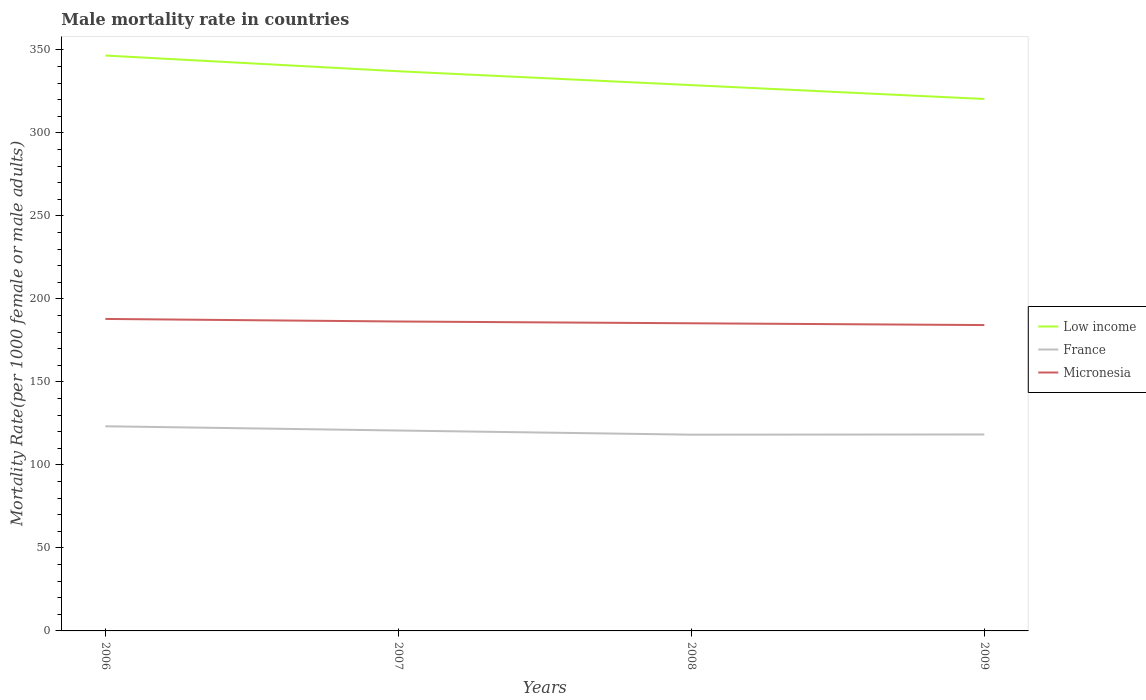Across all years, what is the maximum male mortality rate in France?
Your answer should be very brief. 118.23. In which year was the male mortality rate in France maximum?
Offer a terse response. 2008. What is the total male mortality rate in Low income in the graph?
Provide a succinct answer. 8.34. What is the difference between the highest and the second highest male mortality rate in Micronesia?
Provide a succinct answer. 3.68. What is the difference between the highest and the lowest male mortality rate in France?
Provide a short and direct response. 2. Is the male mortality rate in France strictly greater than the male mortality rate in Micronesia over the years?
Provide a succinct answer. Yes. How many lines are there?
Provide a succinct answer. 3. How many years are there in the graph?
Give a very brief answer. 4. What is the difference between two consecutive major ticks on the Y-axis?
Keep it short and to the point. 50. Does the graph contain any zero values?
Your answer should be very brief. No. How many legend labels are there?
Keep it short and to the point. 3. What is the title of the graph?
Make the answer very short. Male mortality rate in countries. What is the label or title of the Y-axis?
Your answer should be very brief. Mortality Rate(per 1000 female or male adults). What is the Mortality Rate(per 1000 female or male adults) in Low income in 2006?
Offer a very short reply. 346.65. What is the Mortality Rate(per 1000 female or male adults) in France in 2006?
Provide a succinct answer. 123.29. What is the Mortality Rate(per 1000 female or male adults) in Micronesia in 2006?
Offer a very short reply. 187.96. What is the Mortality Rate(per 1000 female or male adults) of Low income in 2007?
Keep it short and to the point. 337.17. What is the Mortality Rate(per 1000 female or male adults) of France in 2007?
Offer a terse response. 120.74. What is the Mortality Rate(per 1000 female or male adults) of Micronesia in 2007?
Keep it short and to the point. 186.42. What is the Mortality Rate(per 1000 female or male adults) of Low income in 2008?
Provide a short and direct response. 328.81. What is the Mortality Rate(per 1000 female or male adults) of France in 2008?
Offer a very short reply. 118.23. What is the Mortality Rate(per 1000 female or male adults) in Micronesia in 2008?
Provide a short and direct response. 185.34. What is the Mortality Rate(per 1000 female or male adults) of Low income in 2009?
Ensure brevity in your answer.  320.47. What is the Mortality Rate(per 1000 female or male adults) in France in 2009?
Provide a succinct answer. 118.35. What is the Mortality Rate(per 1000 female or male adults) of Micronesia in 2009?
Make the answer very short. 184.27. Across all years, what is the maximum Mortality Rate(per 1000 female or male adults) in Low income?
Your answer should be compact. 346.65. Across all years, what is the maximum Mortality Rate(per 1000 female or male adults) of France?
Make the answer very short. 123.29. Across all years, what is the maximum Mortality Rate(per 1000 female or male adults) in Micronesia?
Provide a short and direct response. 187.96. Across all years, what is the minimum Mortality Rate(per 1000 female or male adults) of Low income?
Provide a short and direct response. 320.47. Across all years, what is the minimum Mortality Rate(per 1000 female or male adults) in France?
Ensure brevity in your answer.  118.23. Across all years, what is the minimum Mortality Rate(per 1000 female or male adults) of Micronesia?
Your response must be concise. 184.27. What is the total Mortality Rate(per 1000 female or male adults) of Low income in the graph?
Make the answer very short. 1333.11. What is the total Mortality Rate(per 1000 female or male adults) of France in the graph?
Your answer should be compact. 480.61. What is the total Mortality Rate(per 1000 female or male adults) in Micronesia in the graph?
Make the answer very short. 743.99. What is the difference between the Mortality Rate(per 1000 female or male adults) of Low income in 2006 and that in 2007?
Ensure brevity in your answer.  9.47. What is the difference between the Mortality Rate(per 1000 female or male adults) in France in 2006 and that in 2007?
Provide a short and direct response. 2.55. What is the difference between the Mortality Rate(per 1000 female or male adults) in Micronesia in 2006 and that in 2007?
Your response must be concise. 1.54. What is the difference between the Mortality Rate(per 1000 female or male adults) of Low income in 2006 and that in 2008?
Offer a terse response. 17.83. What is the difference between the Mortality Rate(per 1000 female or male adults) of France in 2006 and that in 2008?
Provide a succinct answer. 5.06. What is the difference between the Mortality Rate(per 1000 female or male adults) of Micronesia in 2006 and that in 2008?
Make the answer very short. 2.61. What is the difference between the Mortality Rate(per 1000 female or male adults) of Low income in 2006 and that in 2009?
Offer a very short reply. 26.17. What is the difference between the Mortality Rate(per 1000 female or male adults) in France in 2006 and that in 2009?
Offer a terse response. 4.94. What is the difference between the Mortality Rate(per 1000 female or male adults) in Micronesia in 2006 and that in 2009?
Provide a succinct answer. 3.68. What is the difference between the Mortality Rate(per 1000 female or male adults) of Low income in 2007 and that in 2008?
Make the answer very short. 8.36. What is the difference between the Mortality Rate(per 1000 female or male adults) in France in 2007 and that in 2008?
Give a very brief answer. 2.51. What is the difference between the Mortality Rate(per 1000 female or male adults) of Micronesia in 2007 and that in 2008?
Provide a short and direct response. 1.07. What is the difference between the Mortality Rate(per 1000 female or male adults) in Low income in 2007 and that in 2009?
Provide a succinct answer. 16.7. What is the difference between the Mortality Rate(per 1000 female or male adults) in France in 2007 and that in 2009?
Offer a terse response. 2.39. What is the difference between the Mortality Rate(per 1000 female or male adults) in Micronesia in 2007 and that in 2009?
Make the answer very short. 2.15. What is the difference between the Mortality Rate(per 1000 female or male adults) in Low income in 2008 and that in 2009?
Make the answer very short. 8.34. What is the difference between the Mortality Rate(per 1000 female or male adults) in France in 2008 and that in 2009?
Ensure brevity in your answer.  -0.12. What is the difference between the Mortality Rate(per 1000 female or male adults) of Micronesia in 2008 and that in 2009?
Ensure brevity in your answer.  1.07. What is the difference between the Mortality Rate(per 1000 female or male adults) in Low income in 2006 and the Mortality Rate(per 1000 female or male adults) in France in 2007?
Your answer should be compact. 225.91. What is the difference between the Mortality Rate(per 1000 female or male adults) in Low income in 2006 and the Mortality Rate(per 1000 female or male adults) in Micronesia in 2007?
Make the answer very short. 160.23. What is the difference between the Mortality Rate(per 1000 female or male adults) in France in 2006 and the Mortality Rate(per 1000 female or male adults) in Micronesia in 2007?
Your answer should be very brief. -63.12. What is the difference between the Mortality Rate(per 1000 female or male adults) in Low income in 2006 and the Mortality Rate(per 1000 female or male adults) in France in 2008?
Your answer should be compact. 228.42. What is the difference between the Mortality Rate(per 1000 female or male adults) of Low income in 2006 and the Mortality Rate(per 1000 female or male adults) of Micronesia in 2008?
Ensure brevity in your answer.  161.3. What is the difference between the Mortality Rate(per 1000 female or male adults) of France in 2006 and the Mortality Rate(per 1000 female or male adults) of Micronesia in 2008?
Give a very brief answer. -62.05. What is the difference between the Mortality Rate(per 1000 female or male adults) in Low income in 2006 and the Mortality Rate(per 1000 female or male adults) in France in 2009?
Your response must be concise. 228.3. What is the difference between the Mortality Rate(per 1000 female or male adults) of Low income in 2006 and the Mortality Rate(per 1000 female or male adults) of Micronesia in 2009?
Ensure brevity in your answer.  162.38. What is the difference between the Mortality Rate(per 1000 female or male adults) of France in 2006 and the Mortality Rate(per 1000 female or male adults) of Micronesia in 2009?
Provide a short and direct response. -60.98. What is the difference between the Mortality Rate(per 1000 female or male adults) of Low income in 2007 and the Mortality Rate(per 1000 female or male adults) of France in 2008?
Your answer should be very brief. 218.95. What is the difference between the Mortality Rate(per 1000 female or male adults) of Low income in 2007 and the Mortality Rate(per 1000 female or male adults) of Micronesia in 2008?
Provide a short and direct response. 151.83. What is the difference between the Mortality Rate(per 1000 female or male adults) of France in 2007 and the Mortality Rate(per 1000 female or male adults) of Micronesia in 2008?
Provide a succinct answer. -64.6. What is the difference between the Mortality Rate(per 1000 female or male adults) in Low income in 2007 and the Mortality Rate(per 1000 female or male adults) in France in 2009?
Give a very brief answer. 218.82. What is the difference between the Mortality Rate(per 1000 female or male adults) of Low income in 2007 and the Mortality Rate(per 1000 female or male adults) of Micronesia in 2009?
Your answer should be compact. 152.9. What is the difference between the Mortality Rate(per 1000 female or male adults) in France in 2007 and the Mortality Rate(per 1000 female or male adults) in Micronesia in 2009?
Offer a very short reply. -63.53. What is the difference between the Mortality Rate(per 1000 female or male adults) in Low income in 2008 and the Mortality Rate(per 1000 female or male adults) in France in 2009?
Your response must be concise. 210.46. What is the difference between the Mortality Rate(per 1000 female or male adults) in Low income in 2008 and the Mortality Rate(per 1000 female or male adults) in Micronesia in 2009?
Offer a terse response. 144.54. What is the difference between the Mortality Rate(per 1000 female or male adults) of France in 2008 and the Mortality Rate(per 1000 female or male adults) of Micronesia in 2009?
Your answer should be very brief. -66.04. What is the average Mortality Rate(per 1000 female or male adults) of Low income per year?
Make the answer very short. 333.28. What is the average Mortality Rate(per 1000 female or male adults) of France per year?
Make the answer very short. 120.15. What is the average Mortality Rate(per 1000 female or male adults) of Micronesia per year?
Keep it short and to the point. 186. In the year 2006, what is the difference between the Mortality Rate(per 1000 female or male adults) of Low income and Mortality Rate(per 1000 female or male adults) of France?
Your answer should be very brief. 223.35. In the year 2006, what is the difference between the Mortality Rate(per 1000 female or male adults) of Low income and Mortality Rate(per 1000 female or male adults) of Micronesia?
Your answer should be compact. 158.69. In the year 2006, what is the difference between the Mortality Rate(per 1000 female or male adults) of France and Mortality Rate(per 1000 female or male adults) of Micronesia?
Give a very brief answer. -64.66. In the year 2007, what is the difference between the Mortality Rate(per 1000 female or male adults) of Low income and Mortality Rate(per 1000 female or male adults) of France?
Offer a very short reply. 216.43. In the year 2007, what is the difference between the Mortality Rate(per 1000 female or male adults) of Low income and Mortality Rate(per 1000 female or male adults) of Micronesia?
Your answer should be very brief. 150.76. In the year 2007, what is the difference between the Mortality Rate(per 1000 female or male adults) in France and Mortality Rate(per 1000 female or male adults) in Micronesia?
Your answer should be compact. -65.68. In the year 2008, what is the difference between the Mortality Rate(per 1000 female or male adults) of Low income and Mortality Rate(per 1000 female or male adults) of France?
Provide a short and direct response. 210.59. In the year 2008, what is the difference between the Mortality Rate(per 1000 female or male adults) in Low income and Mortality Rate(per 1000 female or male adults) in Micronesia?
Your response must be concise. 143.47. In the year 2008, what is the difference between the Mortality Rate(per 1000 female or male adults) of France and Mortality Rate(per 1000 female or male adults) of Micronesia?
Your response must be concise. -67.11. In the year 2009, what is the difference between the Mortality Rate(per 1000 female or male adults) in Low income and Mortality Rate(per 1000 female or male adults) in France?
Offer a terse response. 202.12. In the year 2009, what is the difference between the Mortality Rate(per 1000 female or male adults) of Low income and Mortality Rate(per 1000 female or male adults) of Micronesia?
Give a very brief answer. 136.2. In the year 2009, what is the difference between the Mortality Rate(per 1000 female or male adults) in France and Mortality Rate(per 1000 female or male adults) in Micronesia?
Offer a very short reply. -65.92. What is the ratio of the Mortality Rate(per 1000 female or male adults) of Low income in 2006 to that in 2007?
Keep it short and to the point. 1.03. What is the ratio of the Mortality Rate(per 1000 female or male adults) of France in 2006 to that in 2007?
Provide a succinct answer. 1.02. What is the ratio of the Mortality Rate(per 1000 female or male adults) in Micronesia in 2006 to that in 2007?
Ensure brevity in your answer.  1.01. What is the ratio of the Mortality Rate(per 1000 female or male adults) in Low income in 2006 to that in 2008?
Make the answer very short. 1.05. What is the ratio of the Mortality Rate(per 1000 female or male adults) of France in 2006 to that in 2008?
Offer a very short reply. 1.04. What is the ratio of the Mortality Rate(per 1000 female or male adults) of Micronesia in 2006 to that in 2008?
Offer a terse response. 1.01. What is the ratio of the Mortality Rate(per 1000 female or male adults) of Low income in 2006 to that in 2009?
Offer a terse response. 1.08. What is the ratio of the Mortality Rate(per 1000 female or male adults) of France in 2006 to that in 2009?
Give a very brief answer. 1.04. What is the ratio of the Mortality Rate(per 1000 female or male adults) of Low income in 2007 to that in 2008?
Make the answer very short. 1.03. What is the ratio of the Mortality Rate(per 1000 female or male adults) of France in 2007 to that in 2008?
Your answer should be compact. 1.02. What is the ratio of the Mortality Rate(per 1000 female or male adults) of Low income in 2007 to that in 2009?
Offer a terse response. 1.05. What is the ratio of the Mortality Rate(per 1000 female or male adults) of France in 2007 to that in 2009?
Make the answer very short. 1.02. What is the ratio of the Mortality Rate(per 1000 female or male adults) in Micronesia in 2007 to that in 2009?
Your response must be concise. 1.01. What is the ratio of the Mortality Rate(per 1000 female or male adults) in Low income in 2008 to that in 2009?
Give a very brief answer. 1.03. What is the ratio of the Mortality Rate(per 1000 female or male adults) in France in 2008 to that in 2009?
Ensure brevity in your answer.  1. What is the ratio of the Mortality Rate(per 1000 female or male adults) in Micronesia in 2008 to that in 2009?
Provide a succinct answer. 1.01. What is the difference between the highest and the second highest Mortality Rate(per 1000 female or male adults) of Low income?
Keep it short and to the point. 9.47. What is the difference between the highest and the second highest Mortality Rate(per 1000 female or male adults) in France?
Provide a short and direct response. 2.55. What is the difference between the highest and the second highest Mortality Rate(per 1000 female or male adults) of Micronesia?
Offer a very short reply. 1.54. What is the difference between the highest and the lowest Mortality Rate(per 1000 female or male adults) in Low income?
Ensure brevity in your answer.  26.17. What is the difference between the highest and the lowest Mortality Rate(per 1000 female or male adults) of France?
Give a very brief answer. 5.06. What is the difference between the highest and the lowest Mortality Rate(per 1000 female or male adults) of Micronesia?
Your answer should be compact. 3.68. 